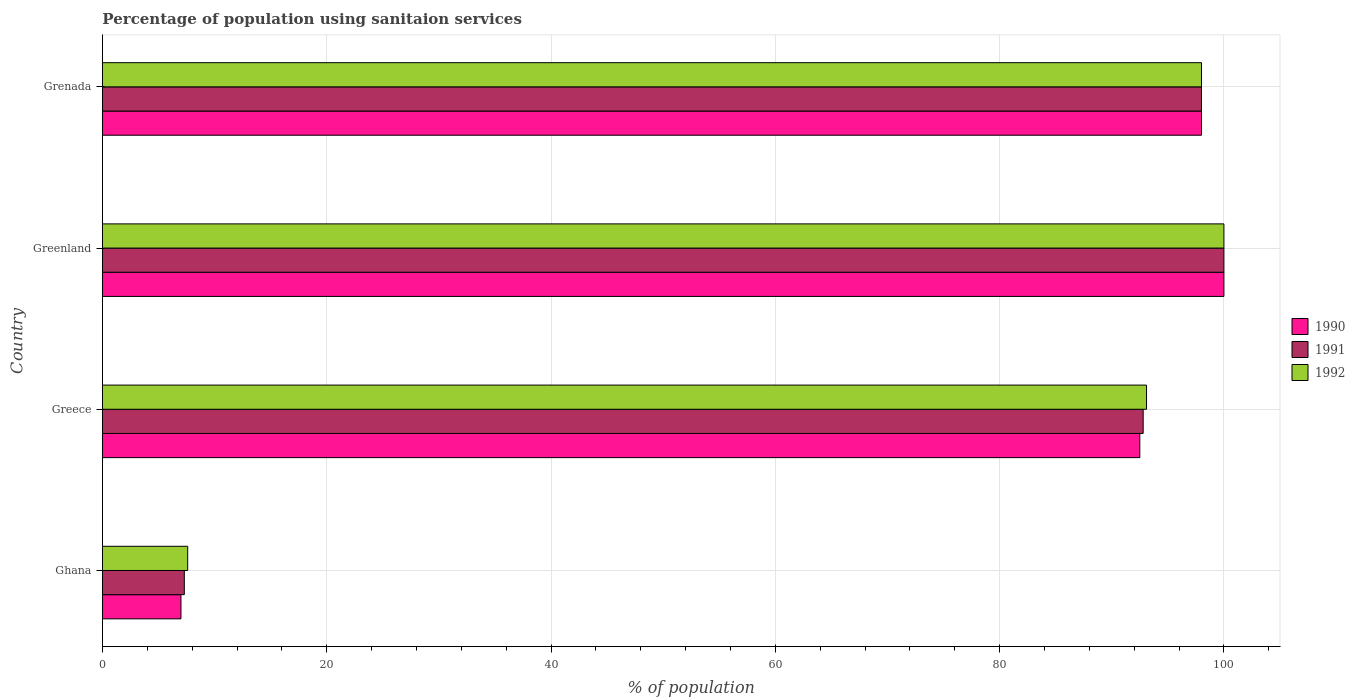How many different coloured bars are there?
Provide a short and direct response. 3. How many groups of bars are there?
Provide a short and direct response. 4. Are the number of bars per tick equal to the number of legend labels?
Provide a succinct answer. Yes. Are the number of bars on each tick of the Y-axis equal?
Offer a terse response. Yes. How many bars are there on the 2nd tick from the bottom?
Provide a short and direct response. 3. What is the label of the 1st group of bars from the top?
Make the answer very short. Grenada. What is the percentage of population using sanitaion services in 1992 in Ghana?
Give a very brief answer. 7.6. Across all countries, what is the maximum percentage of population using sanitaion services in 1990?
Provide a succinct answer. 100. In which country was the percentage of population using sanitaion services in 1991 maximum?
Offer a terse response. Greenland. In which country was the percentage of population using sanitaion services in 1990 minimum?
Provide a short and direct response. Ghana. What is the total percentage of population using sanitaion services in 1991 in the graph?
Your answer should be compact. 298.1. What is the difference between the percentage of population using sanitaion services in 1991 in Ghana and that in Grenada?
Offer a terse response. -90.7. What is the difference between the percentage of population using sanitaion services in 1991 in Greece and the percentage of population using sanitaion services in 1990 in Greenland?
Give a very brief answer. -7.2. What is the average percentage of population using sanitaion services in 1992 per country?
Provide a short and direct response. 74.67. In how many countries, is the percentage of population using sanitaion services in 1992 greater than 84 %?
Ensure brevity in your answer.  3. What is the ratio of the percentage of population using sanitaion services in 1992 in Ghana to that in Greenland?
Provide a succinct answer. 0.08. Is the difference between the percentage of population using sanitaion services in 1992 in Ghana and Greece greater than the difference between the percentage of population using sanitaion services in 1990 in Ghana and Greece?
Your answer should be compact. No. What is the difference between the highest and the lowest percentage of population using sanitaion services in 1991?
Offer a very short reply. 92.7. In how many countries, is the percentage of population using sanitaion services in 1990 greater than the average percentage of population using sanitaion services in 1990 taken over all countries?
Your answer should be very brief. 3. Is the sum of the percentage of population using sanitaion services in 1991 in Greece and Grenada greater than the maximum percentage of population using sanitaion services in 1992 across all countries?
Ensure brevity in your answer.  Yes. What does the 2nd bar from the bottom in Grenada represents?
Keep it short and to the point. 1991. Is it the case that in every country, the sum of the percentage of population using sanitaion services in 1992 and percentage of population using sanitaion services in 1990 is greater than the percentage of population using sanitaion services in 1991?
Keep it short and to the point. Yes. How many countries are there in the graph?
Offer a terse response. 4. What is the difference between two consecutive major ticks on the X-axis?
Make the answer very short. 20. Are the values on the major ticks of X-axis written in scientific E-notation?
Your answer should be very brief. No. Does the graph contain any zero values?
Give a very brief answer. No. Does the graph contain grids?
Provide a short and direct response. Yes. Where does the legend appear in the graph?
Ensure brevity in your answer.  Center right. What is the title of the graph?
Provide a succinct answer. Percentage of population using sanitaion services. Does "1985" appear as one of the legend labels in the graph?
Provide a short and direct response. No. What is the label or title of the X-axis?
Offer a terse response. % of population. What is the % of population in 1990 in Greece?
Your answer should be compact. 92.5. What is the % of population of 1991 in Greece?
Your answer should be compact. 92.8. What is the % of population in 1992 in Greece?
Make the answer very short. 93.1. What is the % of population in 1991 in Greenland?
Make the answer very short. 100. What is the % of population of 1992 in Greenland?
Ensure brevity in your answer.  100. What is the % of population of 1991 in Grenada?
Offer a very short reply. 98. What is the % of population of 1992 in Grenada?
Give a very brief answer. 98. Across all countries, what is the maximum % of population of 1990?
Keep it short and to the point. 100. Across all countries, what is the maximum % of population of 1991?
Keep it short and to the point. 100. Across all countries, what is the maximum % of population of 1992?
Your answer should be very brief. 100. Across all countries, what is the minimum % of population in 1990?
Offer a very short reply. 7. Across all countries, what is the minimum % of population in 1992?
Your answer should be very brief. 7.6. What is the total % of population of 1990 in the graph?
Offer a terse response. 297.5. What is the total % of population of 1991 in the graph?
Keep it short and to the point. 298.1. What is the total % of population in 1992 in the graph?
Your answer should be very brief. 298.7. What is the difference between the % of population in 1990 in Ghana and that in Greece?
Keep it short and to the point. -85.5. What is the difference between the % of population in 1991 in Ghana and that in Greece?
Your answer should be very brief. -85.5. What is the difference between the % of population of 1992 in Ghana and that in Greece?
Your response must be concise. -85.5. What is the difference between the % of population in 1990 in Ghana and that in Greenland?
Your answer should be compact. -93. What is the difference between the % of population of 1991 in Ghana and that in Greenland?
Your answer should be very brief. -92.7. What is the difference between the % of population in 1992 in Ghana and that in Greenland?
Offer a terse response. -92.4. What is the difference between the % of population of 1990 in Ghana and that in Grenada?
Provide a short and direct response. -91. What is the difference between the % of population in 1991 in Ghana and that in Grenada?
Give a very brief answer. -90.7. What is the difference between the % of population of 1992 in Ghana and that in Grenada?
Make the answer very short. -90.4. What is the difference between the % of population in 1990 in Greece and that in Greenland?
Offer a very short reply. -7.5. What is the difference between the % of population of 1992 in Greece and that in Greenland?
Ensure brevity in your answer.  -6.9. What is the difference between the % of population in 1990 in Greece and that in Grenada?
Your answer should be very brief. -5.5. What is the difference between the % of population in 1991 in Greece and that in Grenada?
Keep it short and to the point. -5.2. What is the difference between the % of population of 1990 in Greenland and that in Grenada?
Your response must be concise. 2. What is the difference between the % of population in 1991 in Greenland and that in Grenada?
Provide a succinct answer. 2. What is the difference between the % of population of 1990 in Ghana and the % of population of 1991 in Greece?
Ensure brevity in your answer.  -85.8. What is the difference between the % of population of 1990 in Ghana and the % of population of 1992 in Greece?
Your response must be concise. -86.1. What is the difference between the % of population of 1991 in Ghana and the % of population of 1992 in Greece?
Ensure brevity in your answer.  -85.8. What is the difference between the % of population in 1990 in Ghana and the % of population in 1991 in Greenland?
Your answer should be very brief. -93. What is the difference between the % of population in 1990 in Ghana and the % of population in 1992 in Greenland?
Provide a short and direct response. -93. What is the difference between the % of population in 1991 in Ghana and the % of population in 1992 in Greenland?
Keep it short and to the point. -92.7. What is the difference between the % of population of 1990 in Ghana and the % of population of 1991 in Grenada?
Provide a short and direct response. -91. What is the difference between the % of population of 1990 in Ghana and the % of population of 1992 in Grenada?
Offer a very short reply. -91. What is the difference between the % of population in 1991 in Ghana and the % of population in 1992 in Grenada?
Offer a very short reply. -90.7. What is the difference between the % of population in 1990 in Greece and the % of population in 1992 in Grenada?
Keep it short and to the point. -5.5. What is the difference between the % of population of 1990 in Greenland and the % of population of 1992 in Grenada?
Your answer should be very brief. 2. What is the average % of population in 1990 per country?
Your answer should be very brief. 74.38. What is the average % of population of 1991 per country?
Provide a succinct answer. 74.53. What is the average % of population in 1992 per country?
Your answer should be compact. 74.67. What is the difference between the % of population of 1990 and % of population of 1991 in Ghana?
Offer a very short reply. -0.3. What is the difference between the % of population in 1990 and % of population in 1992 in Ghana?
Give a very brief answer. -0.6. What is the difference between the % of population of 1991 and % of population of 1992 in Ghana?
Ensure brevity in your answer.  -0.3. What is the difference between the % of population of 1990 and % of population of 1991 in Greenland?
Give a very brief answer. 0. What is the difference between the % of population of 1990 and % of population of 1992 in Greenland?
Your answer should be compact. 0. What is the difference between the % of population of 1991 and % of population of 1992 in Grenada?
Offer a very short reply. 0. What is the ratio of the % of population of 1990 in Ghana to that in Greece?
Offer a very short reply. 0.08. What is the ratio of the % of population of 1991 in Ghana to that in Greece?
Keep it short and to the point. 0.08. What is the ratio of the % of population of 1992 in Ghana to that in Greece?
Make the answer very short. 0.08. What is the ratio of the % of population in 1990 in Ghana to that in Greenland?
Provide a succinct answer. 0.07. What is the ratio of the % of population of 1991 in Ghana to that in Greenland?
Provide a short and direct response. 0.07. What is the ratio of the % of population of 1992 in Ghana to that in Greenland?
Make the answer very short. 0.08. What is the ratio of the % of population in 1990 in Ghana to that in Grenada?
Give a very brief answer. 0.07. What is the ratio of the % of population of 1991 in Ghana to that in Grenada?
Your response must be concise. 0.07. What is the ratio of the % of population in 1992 in Ghana to that in Grenada?
Give a very brief answer. 0.08. What is the ratio of the % of population of 1990 in Greece to that in Greenland?
Offer a terse response. 0.93. What is the ratio of the % of population in 1991 in Greece to that in Greenland?
Give a very brief answer. 0.93. What is the ratio of the % of population of 1990 in Greece to that in Grenada?
Keep it short and to the point. 0.94. What is the ratio of the % of population in 1991 in Greece to that in Grenada?
Provide a short and direct response. 0.95. What is the ratio of the % of population of 1992 in Greece to that in Grenada?
Provide a succinct answer. 0.95. What is the ratio of the % of population in 1990 in Greenland to that in Grenada?
Provide a short and direct response. 1.02. What is the ratio of the % of population in 1991 in Greenland to that in Grenada?
Offer a terse response. 1.02. What is the ratio of the % of population of 1992 in Greenland to that in Grenada?
Offer a terse response. 1.02. What is the difference between the highest and the second highest % of population of 1990?
Offer a terse response. 2. What is the difference between the highest and the second highest % of population in 1991?
Keep it short and to the point. 2. What is the difference between the highest and the lowest % of population of 1990?
Offer a terse response. 93. What is the difference between the highest and the lowest % of population of 1991?
Give a very brief answer. 92.7. What is the difference between the highest and the lowest % of population of 1992?
Your answer should be very brief. 92.4. 